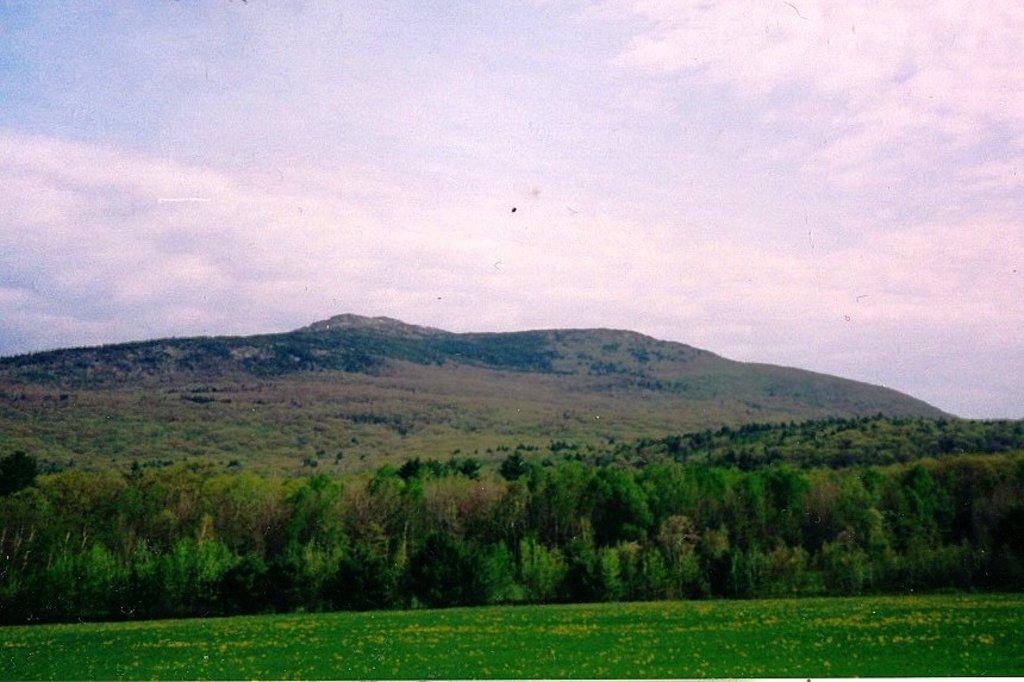Can you describe this image briefly? In this image I can see trees in green color, background I can see few mountains and the sky is in white and blue color. 